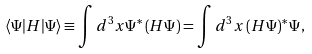<formula> <loc_0><loc_0><loc_500><loc_500>\langle \Psi | H | \Psi \rangle \equiv \int d ^ { 3 } x \Psi ^ { * } \left ( H \Psi \right ) = \int d ^ { 3 } x \left ( H \Psi \right ) ^ { * } \Psi ,</formula> 